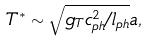Convert formula to latex. <formula><loc_0><loc_0><loc_500><loc_500>T ^ { * } \sim \sqrt { g _ { T } c _ { p h } ^ { 2 } / l _ { p h } } a ,</formula> 